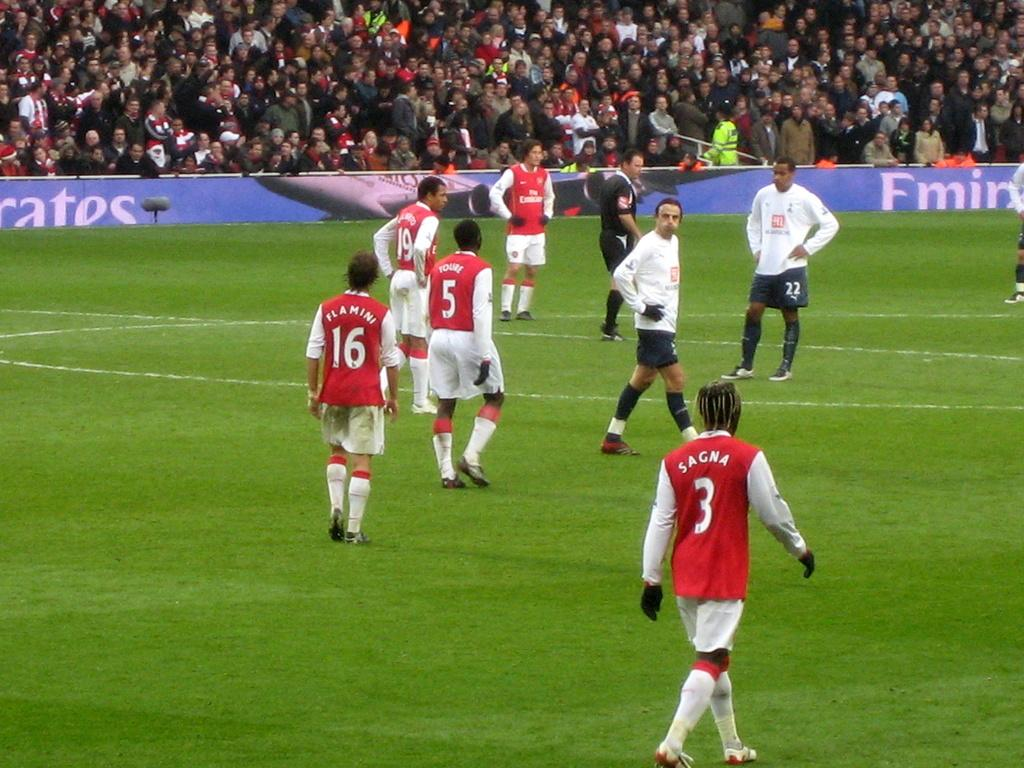What is happening in the foreground of the image? There are people standing on the ground in the image. What can be seen in the background of the image? There is a board visible in the background of the image, and there are people sitting in a stadium. Can you describe the setting of the image? The image appears to be taken at an outdoor event, with people standing on the ground and a stadium in the background. How many planes are flying over the stadium in the image? There are no planes visible in the image; it only shows people standing on the ground and a stadium in the background. Who is the representative of the people sitting in the stadium? The image does not provide information about any representatives of the people sitting in the stadium. 